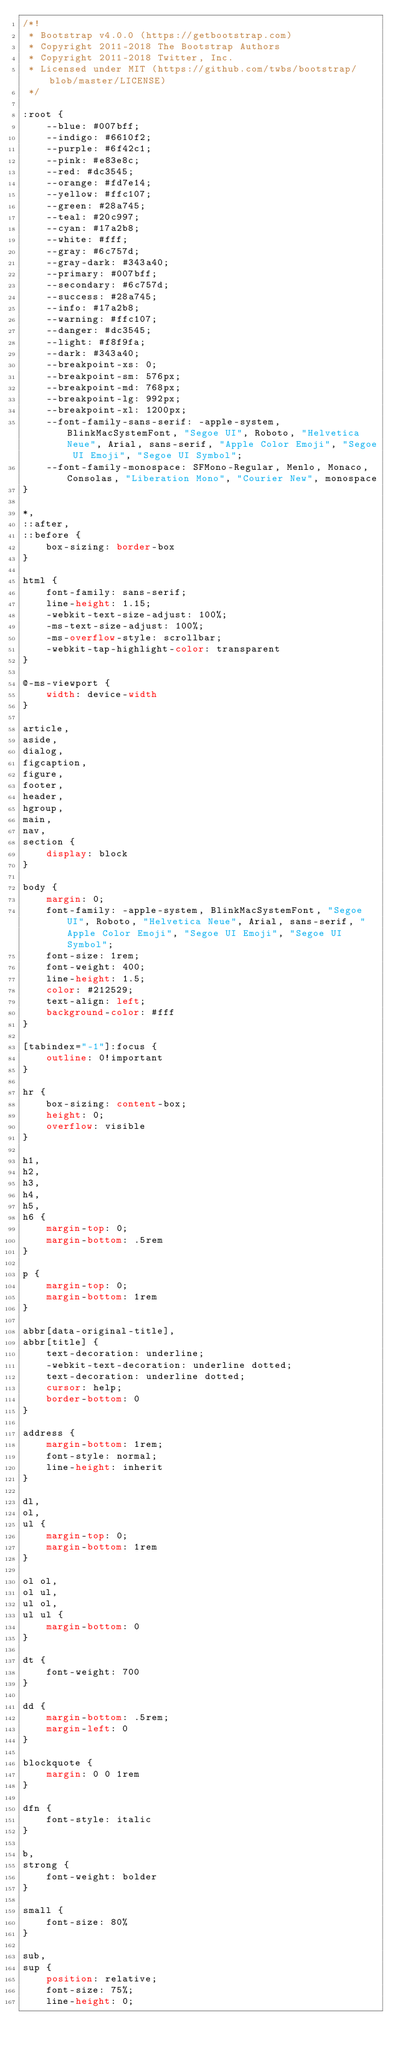<code> <loc_0><loc_0><loc_500><loc_500><_CSS_>/*!
 * Bootstrap v4.0.0 (https://getbootstrap.com)
 * Copyright 2011-2018 The Bootstrap Authors
 * Copyright 2011-2018 Twitter, Inc.
 * Licensed under MIT (https://github.com/twbs/bootstrap/blob/master/LICENSE)
 */

:root {
    --blue: #007bff;
    --indigo: #6610f2;
    --purple: #6f42c1;
    --pink: #e83e8c;
    --red: #dc3545;
    --orange: #fd7e14;
    --yellow: #ffc107;
    --green: #28a745;
    --teal: #20c997;
    --cyan: #17a2b8;
    --white: #fff;
    --gray: #6c757d;
    --gray-dark: #343a40;
    --primary: #007bff;
    --secondary: #6c757d;
    --success: #28a745;
    --info: #17a2b8;
    --warning: #ffc107;
    --danger: #dc3545;
    --light: #f8f9fa;
    --dark: #343a40;
    --breakpoint-xs: 0;
    --breakpoint-sm: 576px;
    --breakpoint-md: 768px;
    --breakpoint-lg: 992px;
    --breakpoint-xl: 1200px;
    --font-family-sans-serif: -apple-system, BlinkMacSystemFont, "Segoe UI", Roboto, "Helvetica Neue", Arial, sans-serif, "Apple Color Emoji", "Segoe UI Emoji", "Segoe UI Symbol";
    --font-family-monospace: SFMono-Regular, Menlo, Monaco, Consolas, "Liberation Mono", "Courier New", monospace
}

*,
::after,
::before {
    box-sizing: border-box
}

html {
    font-family: sans-serif;
    line-height: 1.15;
    -webkit-text-size-adjust: 100%;
    -ms-text-size-adjust: 100%;
    -ms-overflow-style: scrollbar;
    -webkit-tap-highlight-color: transparent
}

@-ms-viewport {
    width: device-width
}

article,
aside,
dialog,
figcaption,
figure,
footer,
header,
hgroup,
main,
nav,
section {
    display: block
}

body {
    margin: 0;
    font-family: -apple-system, BlinkMacSystemFont, "Segoe UI", Roboto, "Helvetica Neue", Arial, sans-serif, "Apple Color Emoji", "Segoe UI Emoji", "Segoe UI Symbol";
    font-size: 1rem;
    font-weight: 400;
    line-height: 1.5;
    color: #212529;
    text-align: left;
    background-color: #fff
}

[tabindex="-1"]:focus {
    outline: 0!important
}

hr {
    box-sizing: content-box;
    height: 0;
    overflow: visible
}

h1,
h2,
h3,
h4,
h5,
h6 {
    margin-top: 0;
    margin-bottom: .5rem
}

p {
    margin-top: 0;
    margin-bottom: 1rem
}

abbr[data-original-title],
abbr[title] {
    text-decoration: underline;
    -webkit-text-decoration: underline dotted;
    text-decoration: underline dotted;
    cursor: help;
    border-bottom: 0
}

address {
    margin-bottom: 1rem;
    font-style: normal;
    line-height: inherit
}

dl,
ol,
ul {
    margin-top: 0;
    margin-bottom: 1rem
}

ol ol,
ol ul,
ul ol,
ul ul {
    margin-bottom: 0
}

dt {
    font-weight: 700
}

dd {
    margin-bottom: .5rem;
    margin-left: 0
}

blockquote {
    margin: 0 0 1rem
}

dfn {
    font-style: italic
}

b,
strong {
    font-weight: bolder
}

small {
    font-size: 80%
}

sub,
sup {
    position: relative;
    font-size: 75%;
    line-height: 0;</code> 